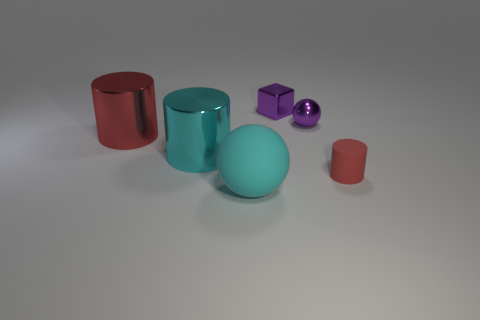Add 1 red matte things. How many objects exist? 7 Subtract all cubes. How many objects are left? 5 Subtract all large gray rubber blocks. Subtract all metal cylinders. How many objects are left? 4 Add 3 purple cubes. How many purple cubes are left? 4 Add 6 large rubber objects. How many large rubber objects exist? 7 Subtract 0 yellow blocks. How many objects are left? 6 